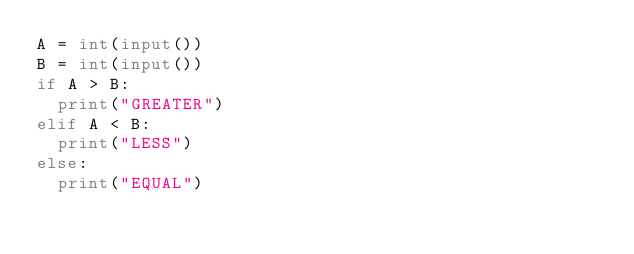Convert code to text. <code><loc_0><loc_0><loc_500><loc_500><_Python_>A = int(input())
B = int(input())
if A > B:
  print("GREATER")
elif A < B:
  print("LESS")
else:
  print("EQUAL")
</code> 